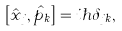Convert formula to latex. <formula><loc_0><loc_0><loc_500><loc_500>\left [ \hat { x } _ { j } , \hat { p } _ { k } \right ] = i \hbar { \delta } _ { j k } ,</formula> 